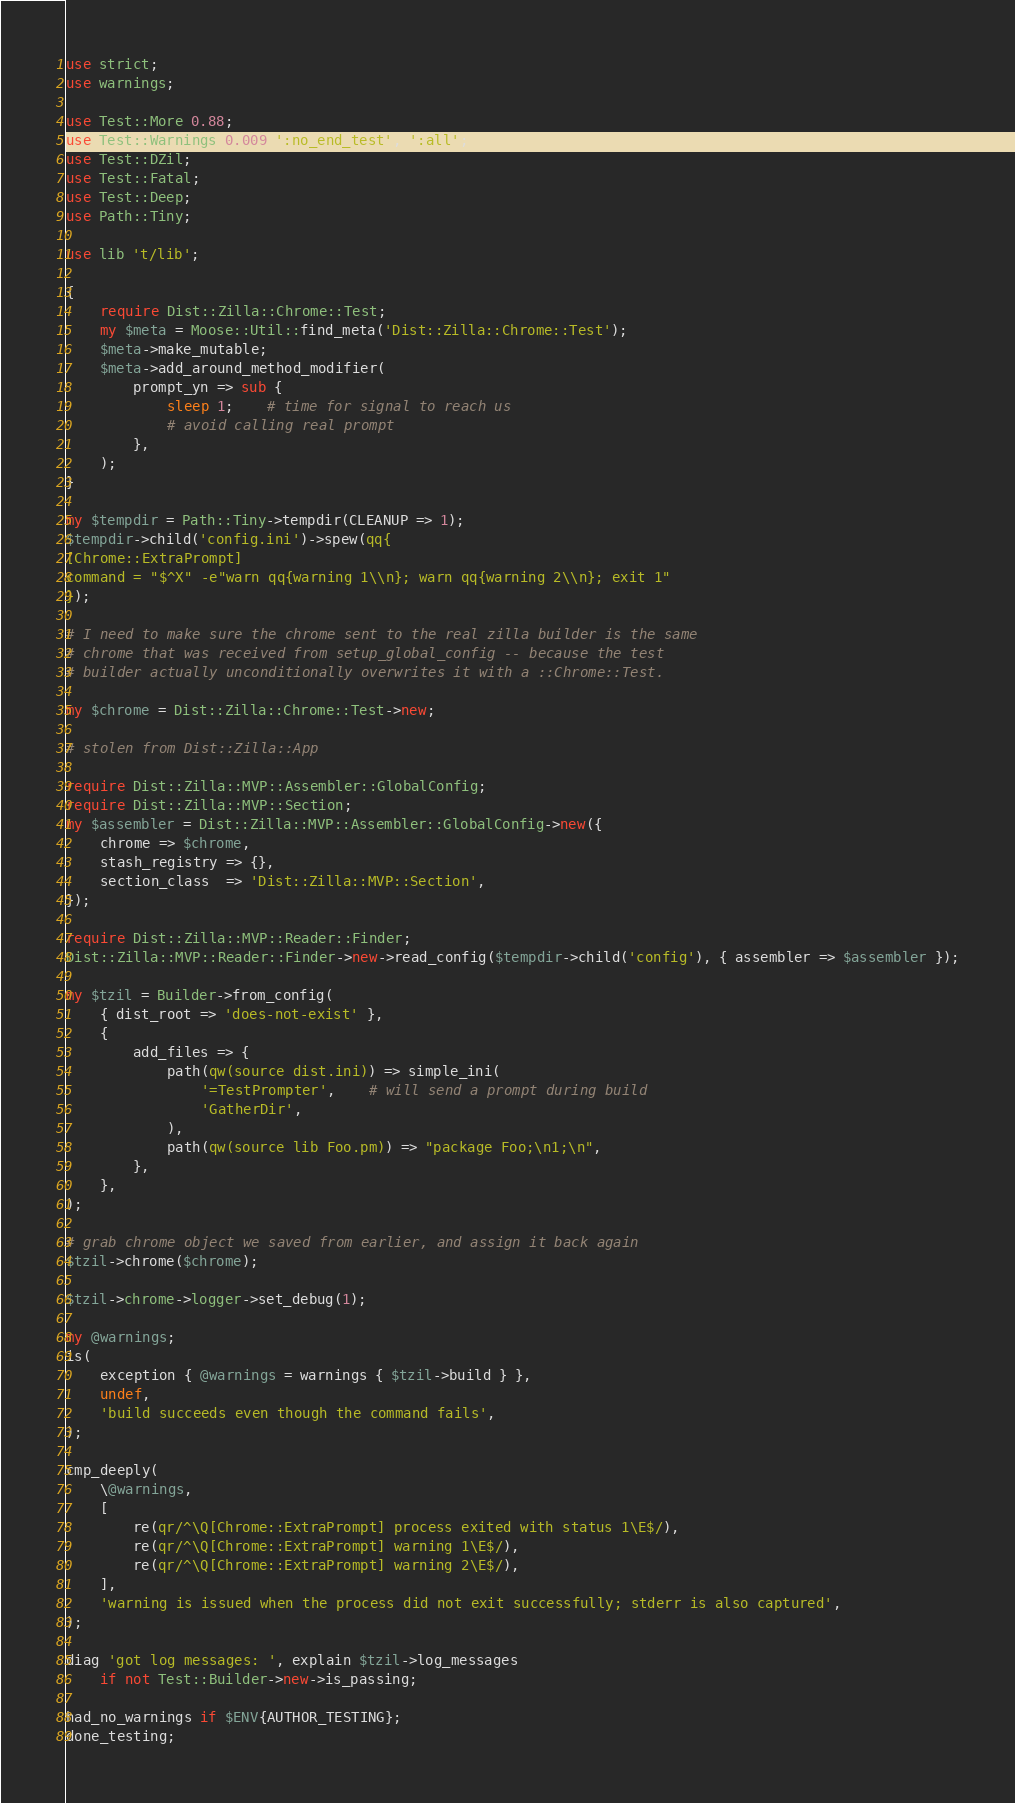Convert code to text. <code><loc_0><loc_0><loc_500><loc_500><_Perl_>use strict;
use warnings;

use Test::More 0.88;
use Test::Warnings 0.009 ':no_end_test', ':all';
use Test::DZil;
use Test::Fatal;
use Test::Deep;
use Path::Tiny;

use lib 't/lib';

{
    require Dist::Zilla::Chrome::Test;
    my $meta = Moose::Util::find_meta('Dist::Zilla::Chrome::Test');
    $meta->make_mutable;
    $meta->add_around_method_modifier(
        prompt_yn => sub {
            sleep 1;    # time for signal to reach us
            # avoid calling real prompt
        },
    );
}

my $tempdir = Path::Tiny->tempdir(CLEANUP => 1);
$tempdir->child('config.ini')->spew(qq{
[Chrome::ExtraPrompt]
command = "$^X" -e"warn qq{warning 1\\n}; warn qq{warning 2\\n}; exit 1"
});

# I need to make sure the chrome sent to the real zilla builder is the same
# chrome that was received from setup_global_config -- because the test
# builder actually unconditionally overwrites it with a ::Chrome::Test.

my $chrome = Dist::Zilla::Chrome::Test->new;

# stolen from Dist::Zilla::App

require Dist::Zilla::MVP::Assembler::GlobalConfig;
require Dist::Zilla::MVP::Section;
my $assembler = Dist::Zilla::MVP::Assembler::GlobalConfig->new({
    chrome => $chrome,
    stash_registry => {},
    section_class  => 'Dist::Zilla::MVP::Section',
});

require Dist::Zilla::MVP::Reader::Finder;
Dist::Zilla::MVP::Reader::Finder->new->read_config($tempdir->child('config'), { assembler => $assembler });

my $tzil = Builder->from_config(
    { dist_root => 'does-not-exist' },
    {
        add_files => {
            path(qw(source dist.ini)) => simple_ini(
                '=TestPrompter',    # will send a prompt during build
                'GatherDir',
            ),
            path(qw(source lib Foo.pm)) => "package Foo;\n1;\n",
        },
    },
);

# grab chrome object we saved from earlier, and assign it back again
$tzil->chrome($chrome);

$tzil->chrome->logger->set_debug(1);

my @warnings;
is(
    exception { @warnings = warnings { $tzil->build } },
    undef,
    'build succeeds even though the command fails',
);

cmp_deeply(
    \@warnings,
    [
        re(qr/^\Q[Chrome::ExtraPrompt] process exited with status 1\E$/),
        re(qr/^\Q[Chrome::ExtraPrompt] warning 1\E$/),
        re(qr/^\Q[Chrome::ExtraPrompt] warning 2\E$/),
    ],
    'warning is issued when the process did not exit successfully; stderr is also captured',
);

diag 'got log messages: ', explain $tzil->log_messages
    if not Test::Builder->new->is_passing;

had_no_warnings if $ENV{AUTHOR_TESTING};
done_testing;
</code> 